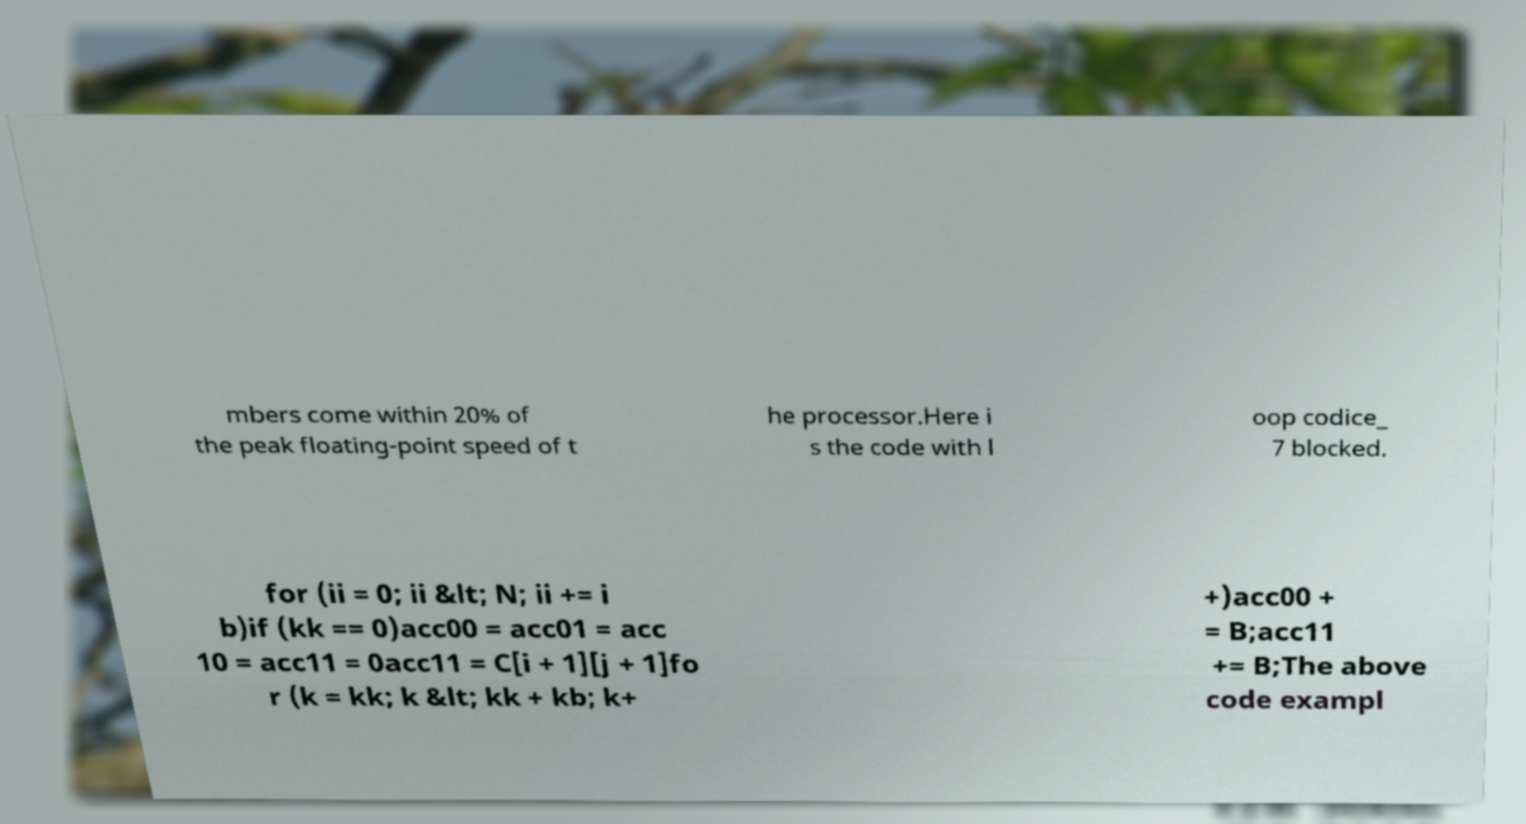What messages or text are displayed in this image? I need them in a readable, typed format. mbers come within 20% of the peak floating-point speed of t he processor.Here i s the code with l oop codice_ 7 blocked. for (ii = 0; ii &lt; N; ii += i b)if (kk == 0)acc00 = acc01 = acc 10 = acc11 = 0acc11 = C[i + 1][j + 1]fo r (k = kk; k &lt; kk + kb; k+ +)acc00 + = B;acc11 += B;The above code exampl 